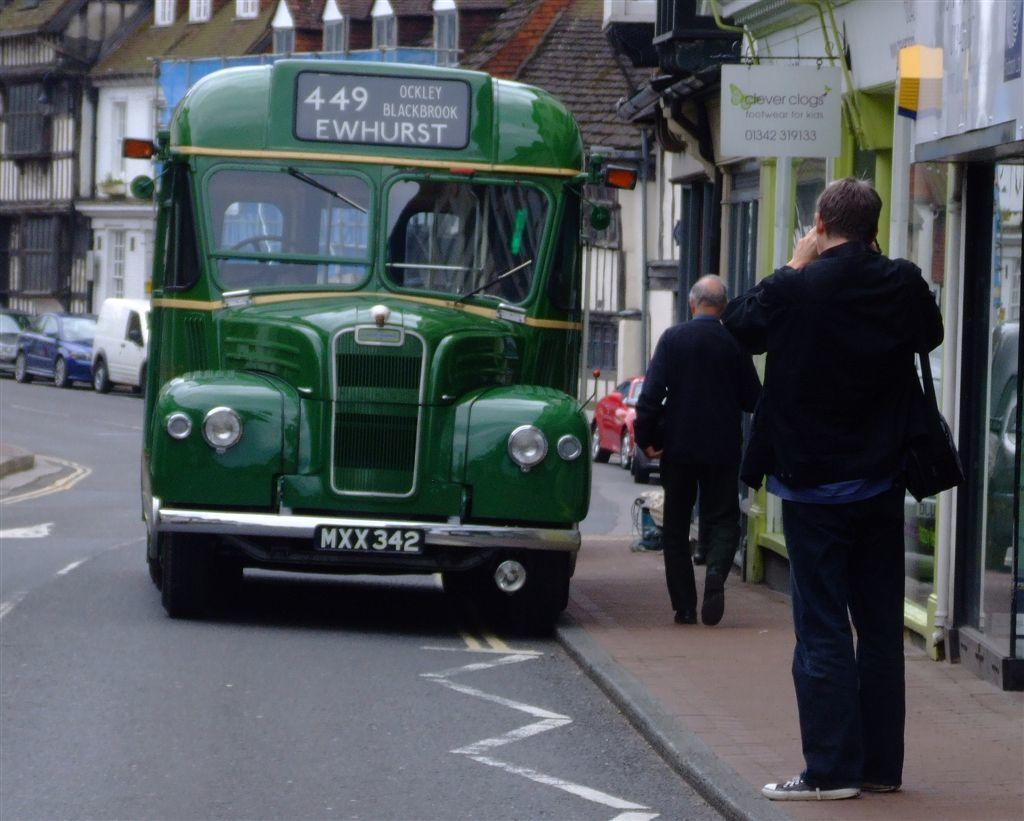<image>
Create a compact narrative representing the image presented. A man takes a picture of a green bus headed to Ewhurst. 